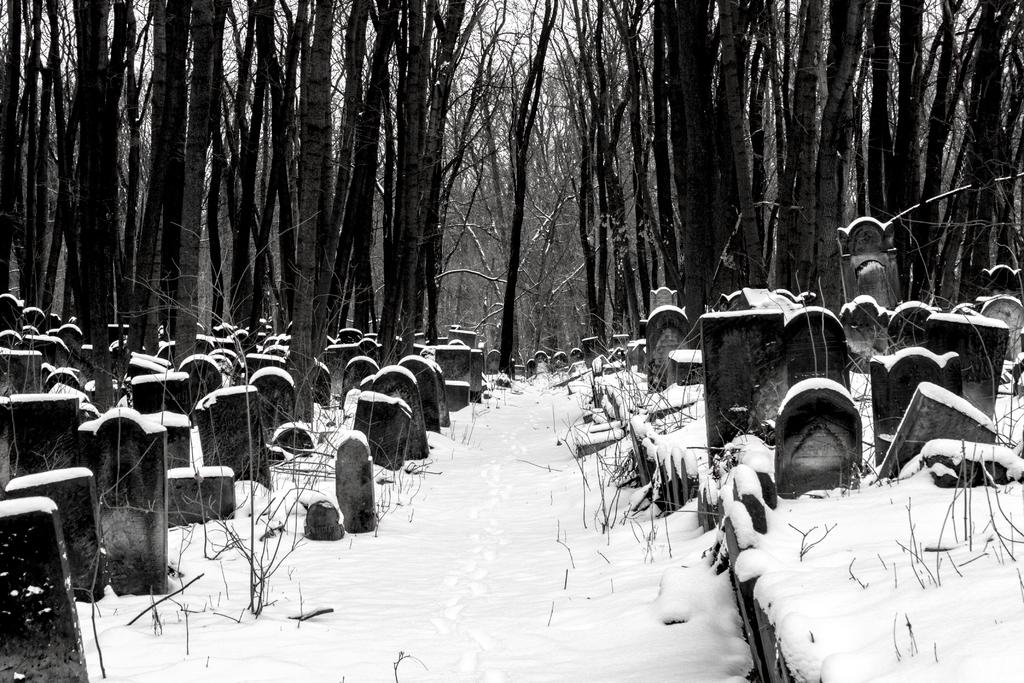What is the color scheme of the image? The image is black and white. What can be seen in the image that represents a final resting place? There is a group of grave stones in the image. What type of vegetation is present in the image? There are plants in the image. What weather condition is depicted in the image? There is snow in the image. What type of natural feature is visible in the image? There is a group of trees in the image. What is visible in the sky in the image? The sky is visible in the image and appears cloudy. Can you see a cord hanging from the trees in the image? There is no cord hanging from the trees in the image. What type of apple is being eaten by the person in the image? There is no person or apple present in the image. 